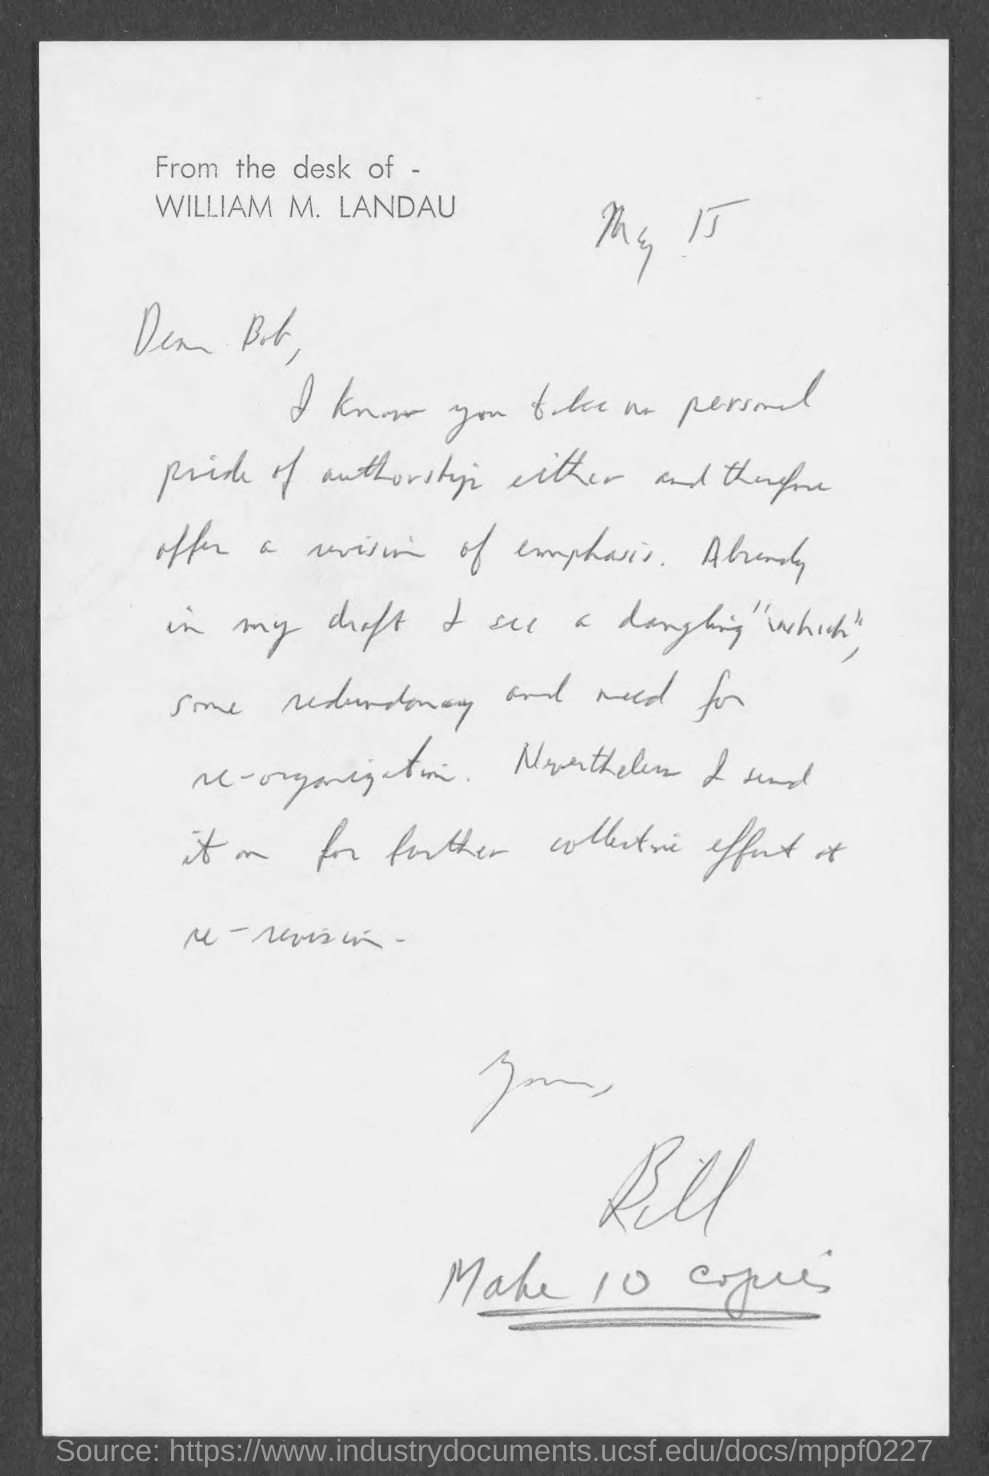This is written from the desk of whom ?
Your answer should be compact. William M . Landau. To whom this letter is written ?
Provide a succinct answer. Bob. 